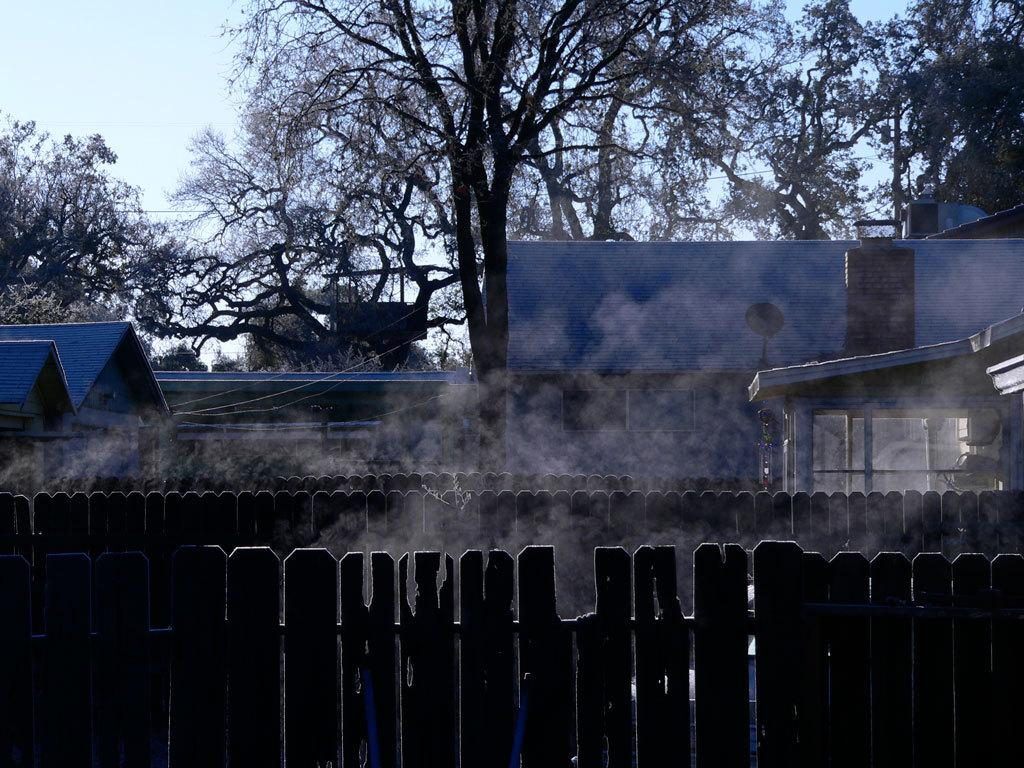What type of fence can be seen in the image? There is a wooden fence in the image. What else is visible in the image besides the fence? There is smoke, wooden houses, trees, and the sky visible in the image. Can you describe the wooden houses in the image? The wooden houses are visible in the image. What is visible in the background of the image? Trees and the sky are visible in the background of the image. What type of feather can be seen on the yak in the image? There is no yak present in the image, and therefore no feather can be observed. What nation is depicted in the image? The image does not depict a specific nation; it features a wooden fence, smoke, wooden houses, trees, and the sky. 